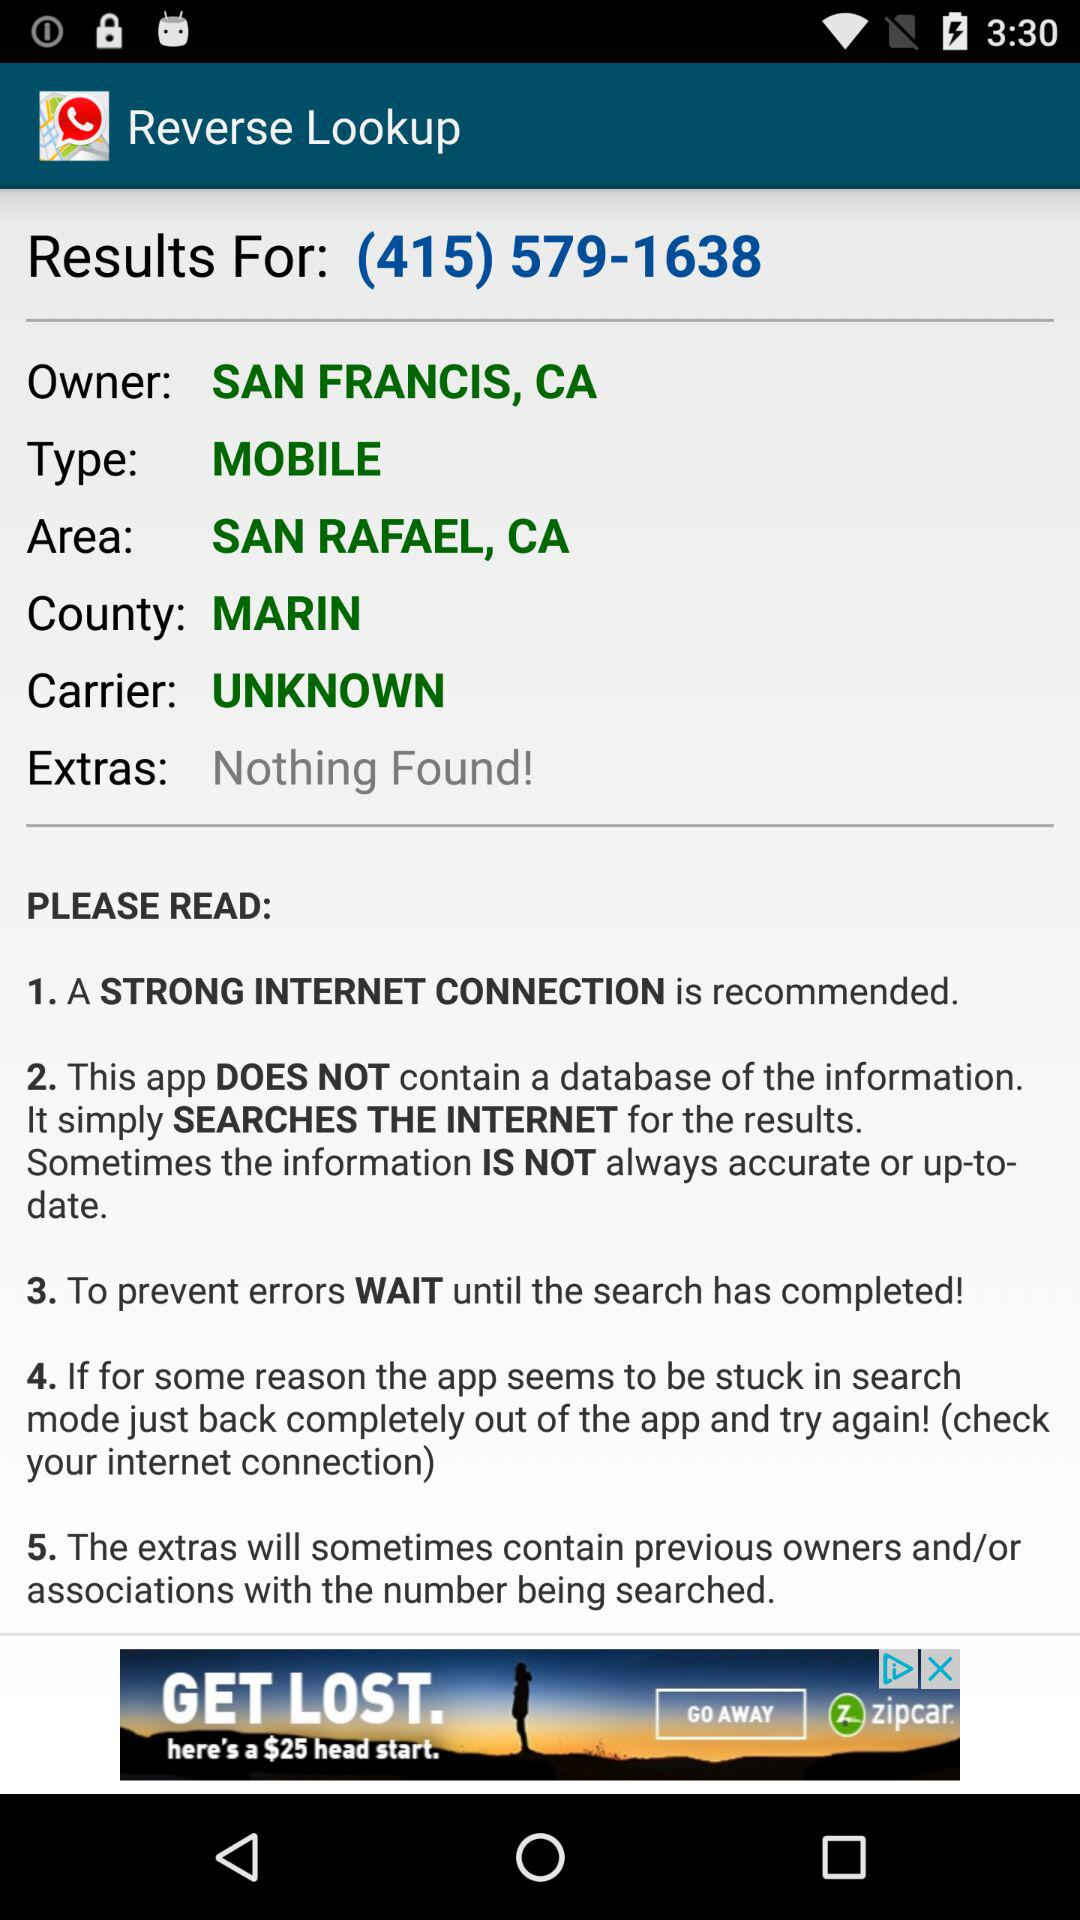What is the type? The type is mobile. 